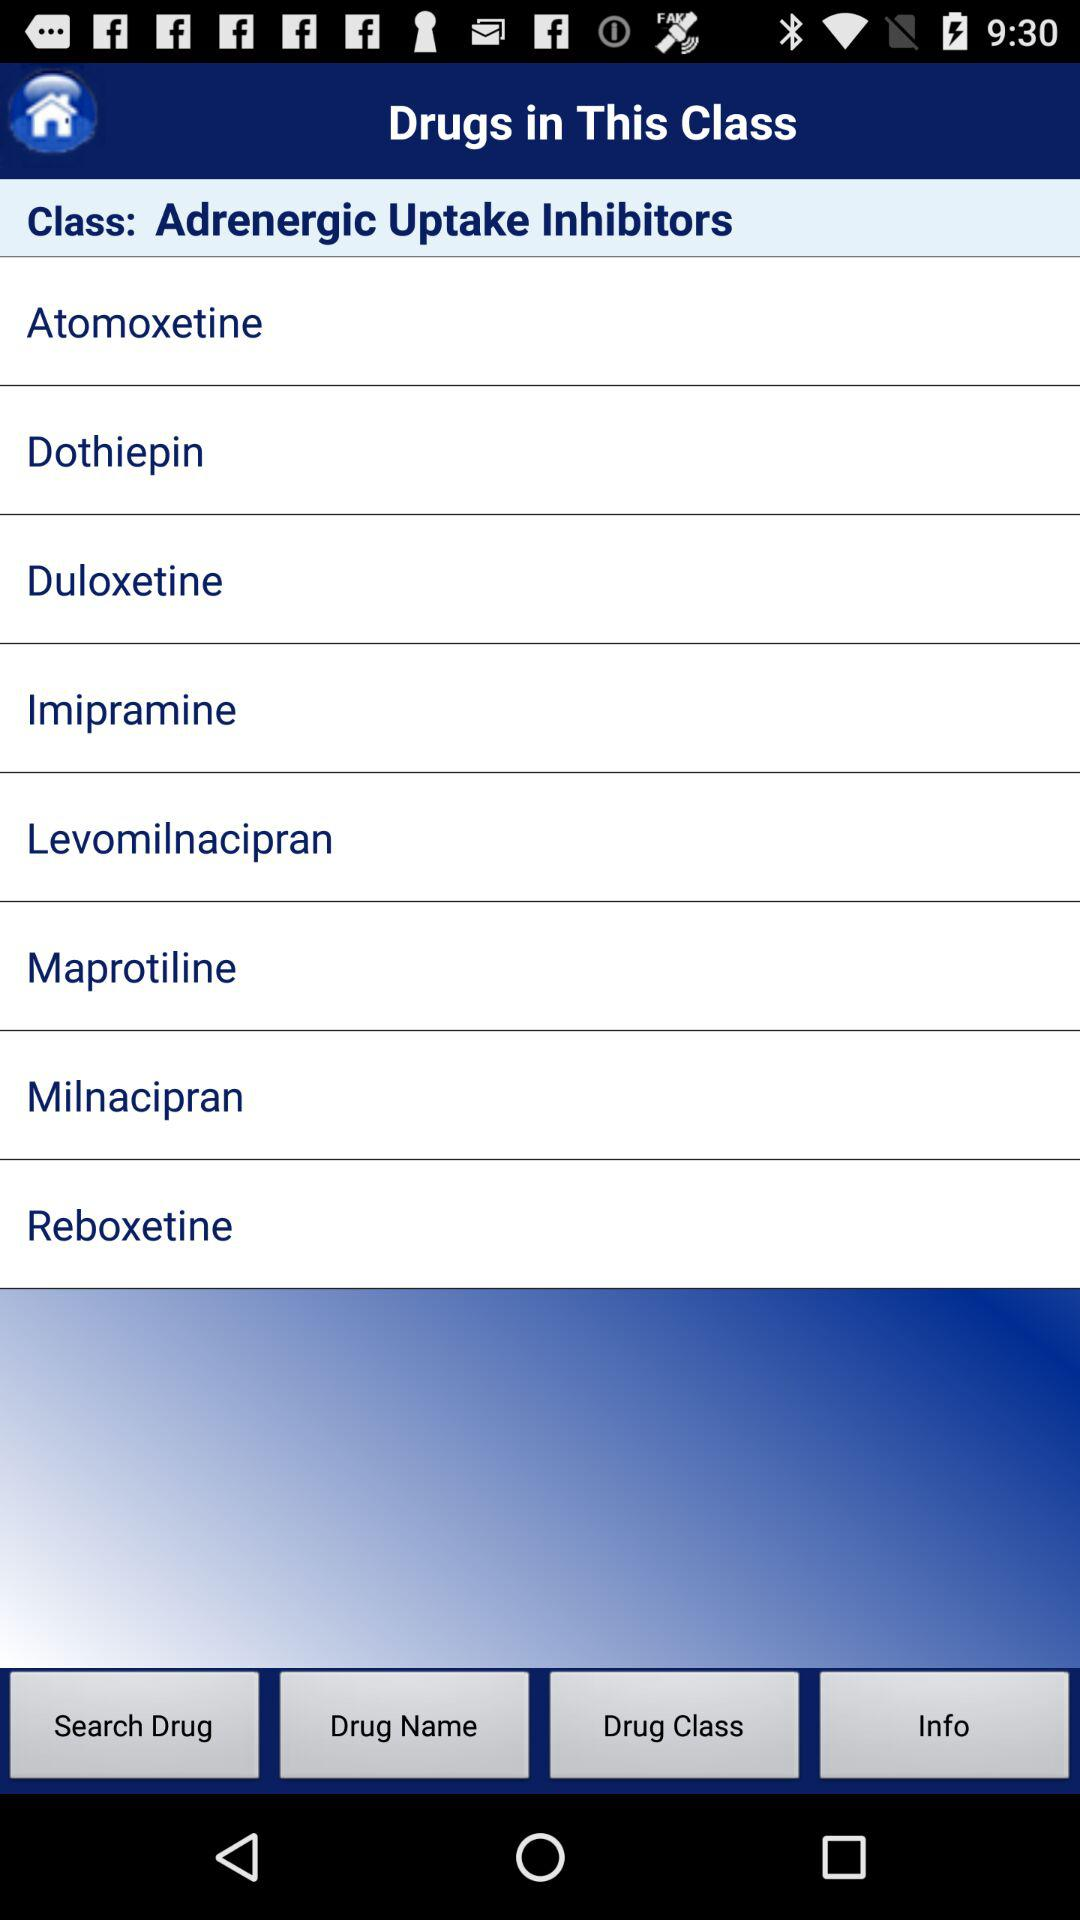What is the name of the class of drug? The name of the class of drug is "Adrenergic Uptake Inhibitors". 